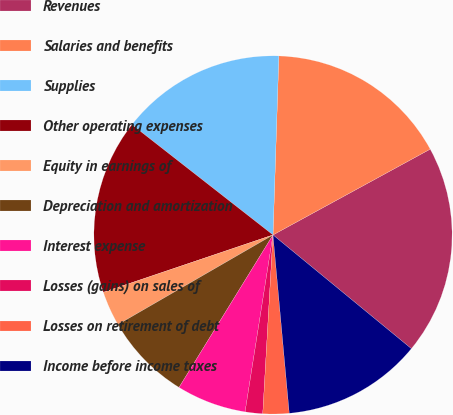Convert chart. <chart><loc_0><loc_0><loc_500><loc_500><pie_chart><fcel>Revenues<fcel>Salaries and benefits<fcel>Supplies<fcel>Other operating expenses<fcel>Equity in earnings of<fcel>Depreciation and amortization<fcel>Interest expense<fcel>Losses (gains) on sales of<fcel>Losses on retirement of debt<fcel>Income before income taxes<nl><fcel>18.9%<fcel>16.53%<fcel>14.96%<fcel>15.75%<fcel>3.15%<fcel>7.87%<fcel>6.3%<fcel>1.58%<fcel>2.36%<fcel>12.6%<nl></chart> 